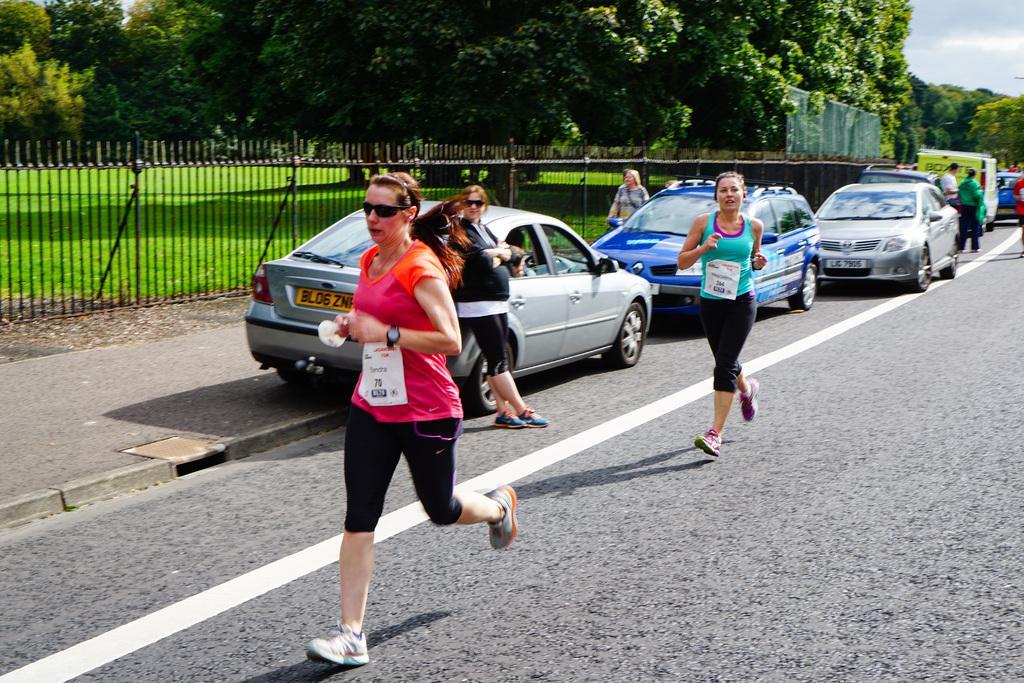How would you summarize this image in a sentence or two? In the background we can see sky, trees. Here we can see fence and grass. We can see vehicles on the road. We can see people. Among them few are standing and few are running on the road. 